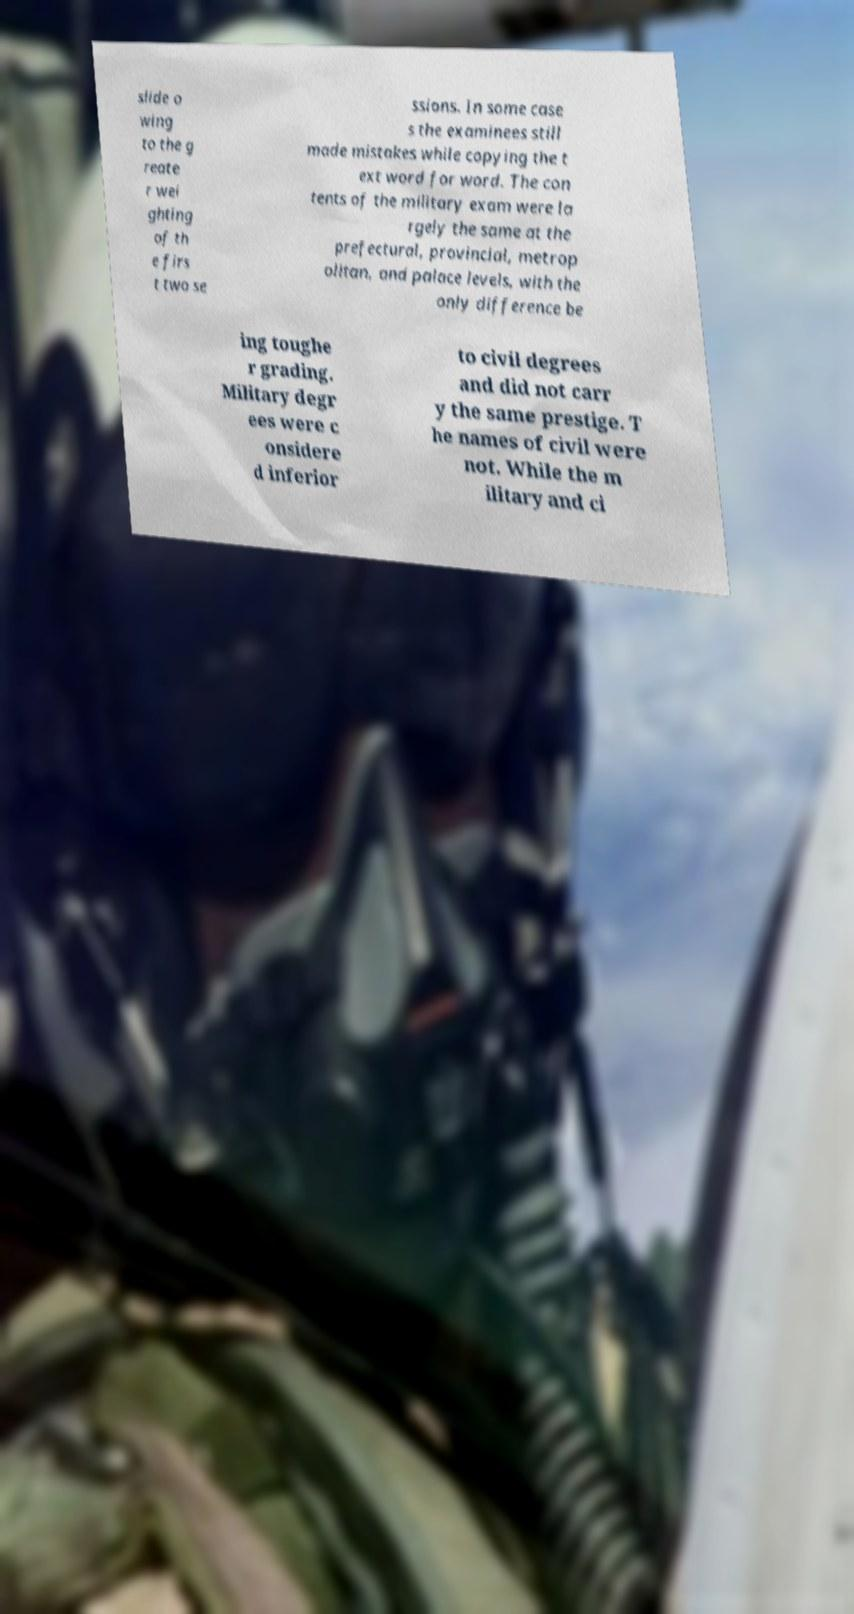Could you assist in decoding the text presented in this image and type it out clearly? slide o wing to the g reate r wei ghting of th e firs t two se ssions. In some case s the examinees still made mistakes while copying the t ext word for word. The con tents of the military exam were la rgely the same at the prefectural, provincial, metrop olitan, and palace levels, with the only difference be ing toughe r grading. Military degr ees were c onsidere d inferior to civil degrees and did not carr y the same prestige. T he names of civil were not. While the m ilitary and ci 